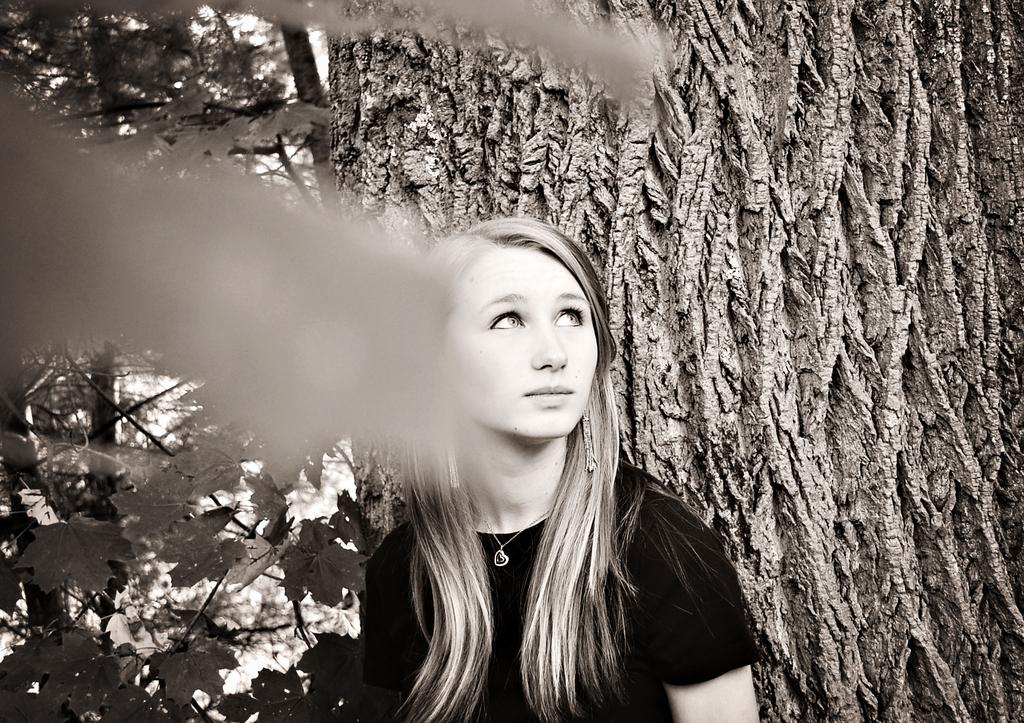What is the main subject of the image? The main subject of the image is a woman. What type of natural scenery is visible in the image? There are trees visible in the image. What is the color scheme of the image? The image is in black and white mode. How many cars can be seen in the image? There are no cars present in the image. What type of transport is being used by the woman in the image? The image does not show any form of transport being used by the woman. 